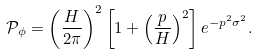<formula> <loc_0><loc_0><loc_500><loc_500>\mathcal { P } _ { \phi } = \left ( \frac { H } { 2 \pi } \right ) ^ { 2 } \left [ 1 + \left ( \frac { p } { H } \right ) ^ { 2 } \right ] e ^ { - p ^ { 2 } \sigma ^ { 2 } } .</formula> 